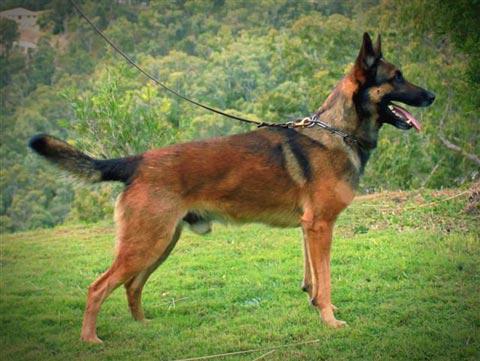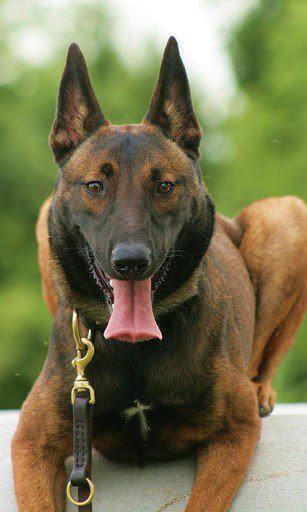The first image is the image on the left, the second image is the image on the right. For the images shown, is this caption "At least one leash is visible in both images." true? Answer yes or no. Yes. The first image is the image on the left, the second image is the image on the right. Evaluate the accuracy of this statement regarding the images: "One german shepherd is standing and the other german shepherd is posed with its front paws extended; at least one dog wears a collar and leash but no dog wears a muzzle.". Is it true? Answer yes or no. Yes. 